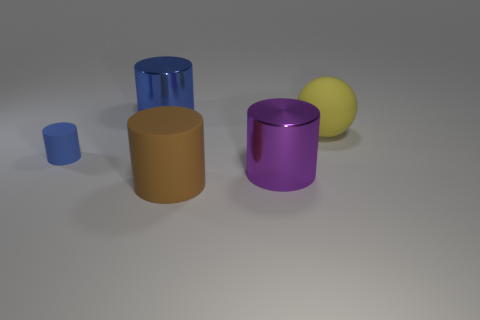Subtract all red blocks. How many blue cylinders are left? 2 Subtract all purple cylinders. How many cylinders are left? 3 Subtract all brown cylinders. How many cylinders are left? 3 Add 5 large blue shiny cylinders. How many objects exist? 10 Subtract 3 cylinders. How many cylinders are left? 1 Subtract all balls. How many objects are left? 4 Subtract all yellow cylinders. Subtract all green cubes. How many cylinders are left? 4 Subtract all green things. Subtract all brown things. How many objects are left? 4 Add 5 big brown objects. How many big brown objects are left? 6 Add 3 small cylinders. How many small cylinders exist? 4 